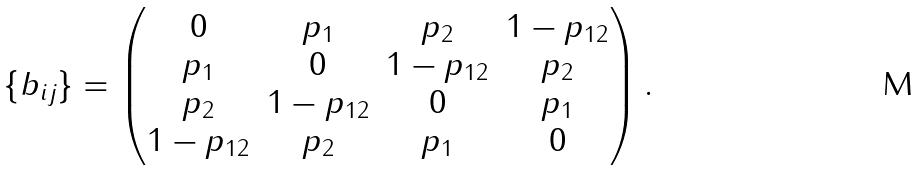Convert formula to latex. <formula><loc_0><loc_0><loc_500><loc_500>\{ b _ { i j } \} = \begin{pmatrix} 0 & p _ { 1 } & p _ { 2 } & 1 - p _ { 1 2 } \\ p _ { 1 } & 0 & 1 - p _ { 1 2 } & p _ { 2 } \\ p _ { 2 } & 1 - p _ { 1 2 } & 0 & p _ { 1 } \\ 1 - p _ { 1 2 } & p _ { 2 } & p _ { 1 } & 0 \end{pmatrix} .</formula> 